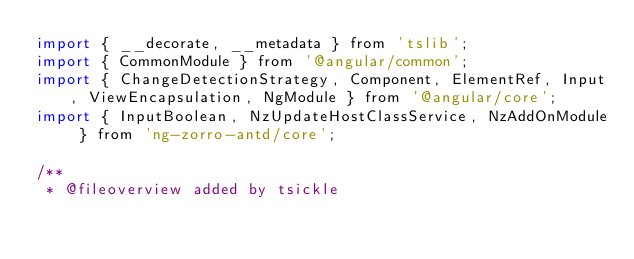Convert code to text. <code><loc_0><loc_0><loc_500><loc_500><_JavaScript_>import { __decorate, __metadata } from 'tslib';
import { CommonModule } from '@angular/common';
import { ChangeDetectionStrategy, Component, ElementRef, Input, ViewEncapsulation, NgModule } from '@angular/core';
import { InputBoolean, NzUpdateHostClassService, NzAddOnModule } from 'ng-zorro-antd/core';

/**
 * @fileoverview added by tsickle</code> 